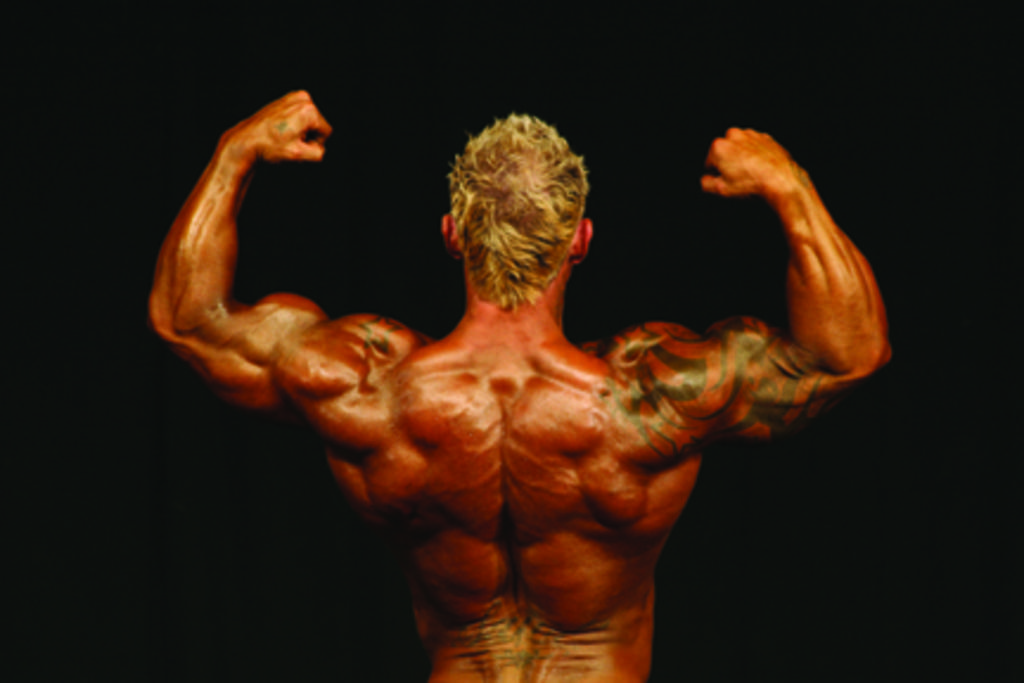What is the main subject in the foreground of the image? There is a person in the foreground of the image. What is the person doing in the image? The person is showing their body. What color is the background of the image? The background of the image is black. How many spiders are crawling on the table in the image? There is no table or spiders present in the image. 